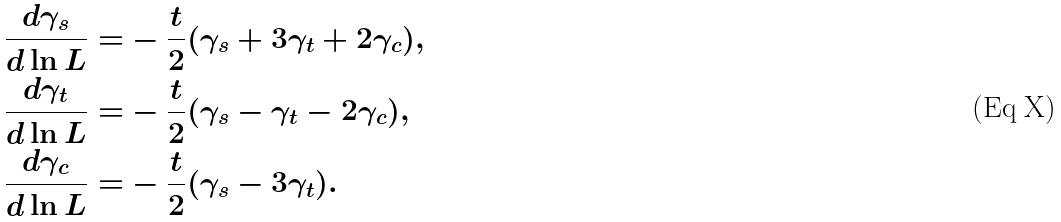<formula> <loc_0><loc_0><loc_500><loc_500>\frac { d \gamma _ { s } } { d \ln L } = & - \frac { t } { 2 } ( \gamma _ { s } + 3 \gamma _ { t } + 2 \gamma _ { c } ) , \\ \frac { d \gamma _ { t } } { d \ln L } = & - \frac { t } { 2 } ( \gamma _ { s } - \gamma _ { t } - 2 \gamma _ { c } ) , \\ \frac { d \gamma _ { c } } { d \ln L } = & - \frac { t } { 2 } ( \gamma _ { s } - 3 \gamma _ { t } ) .</formula> 